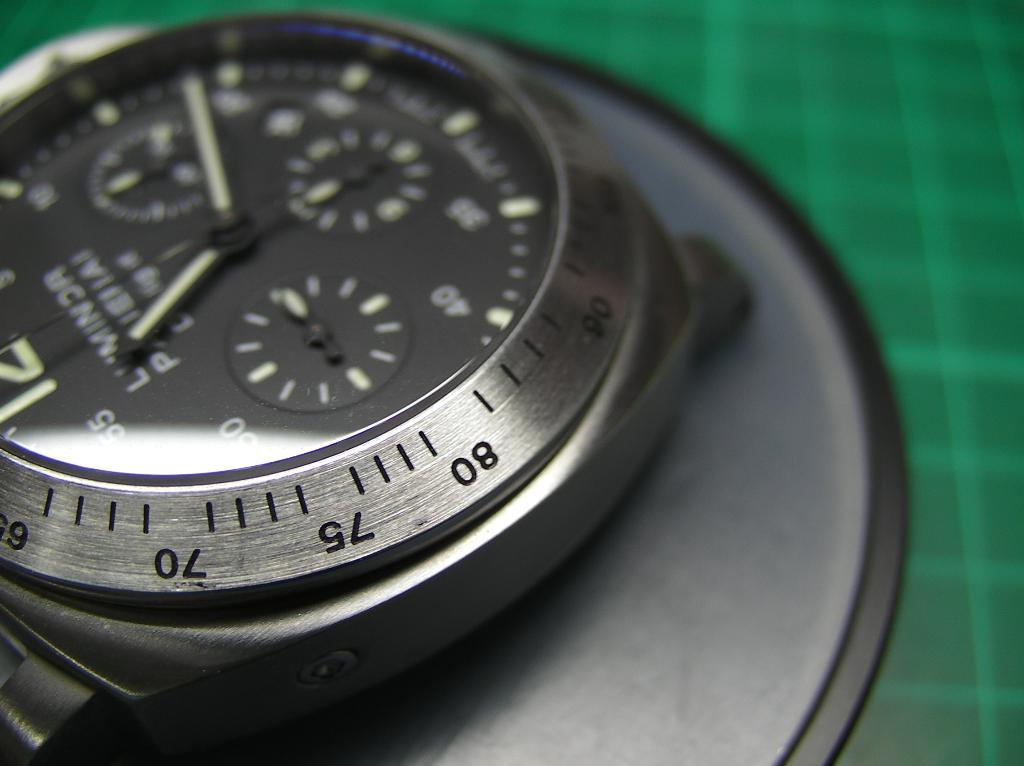Provide a one-sentence caption for the provided image. a safe key that has the letters 80 and 75 on it. 